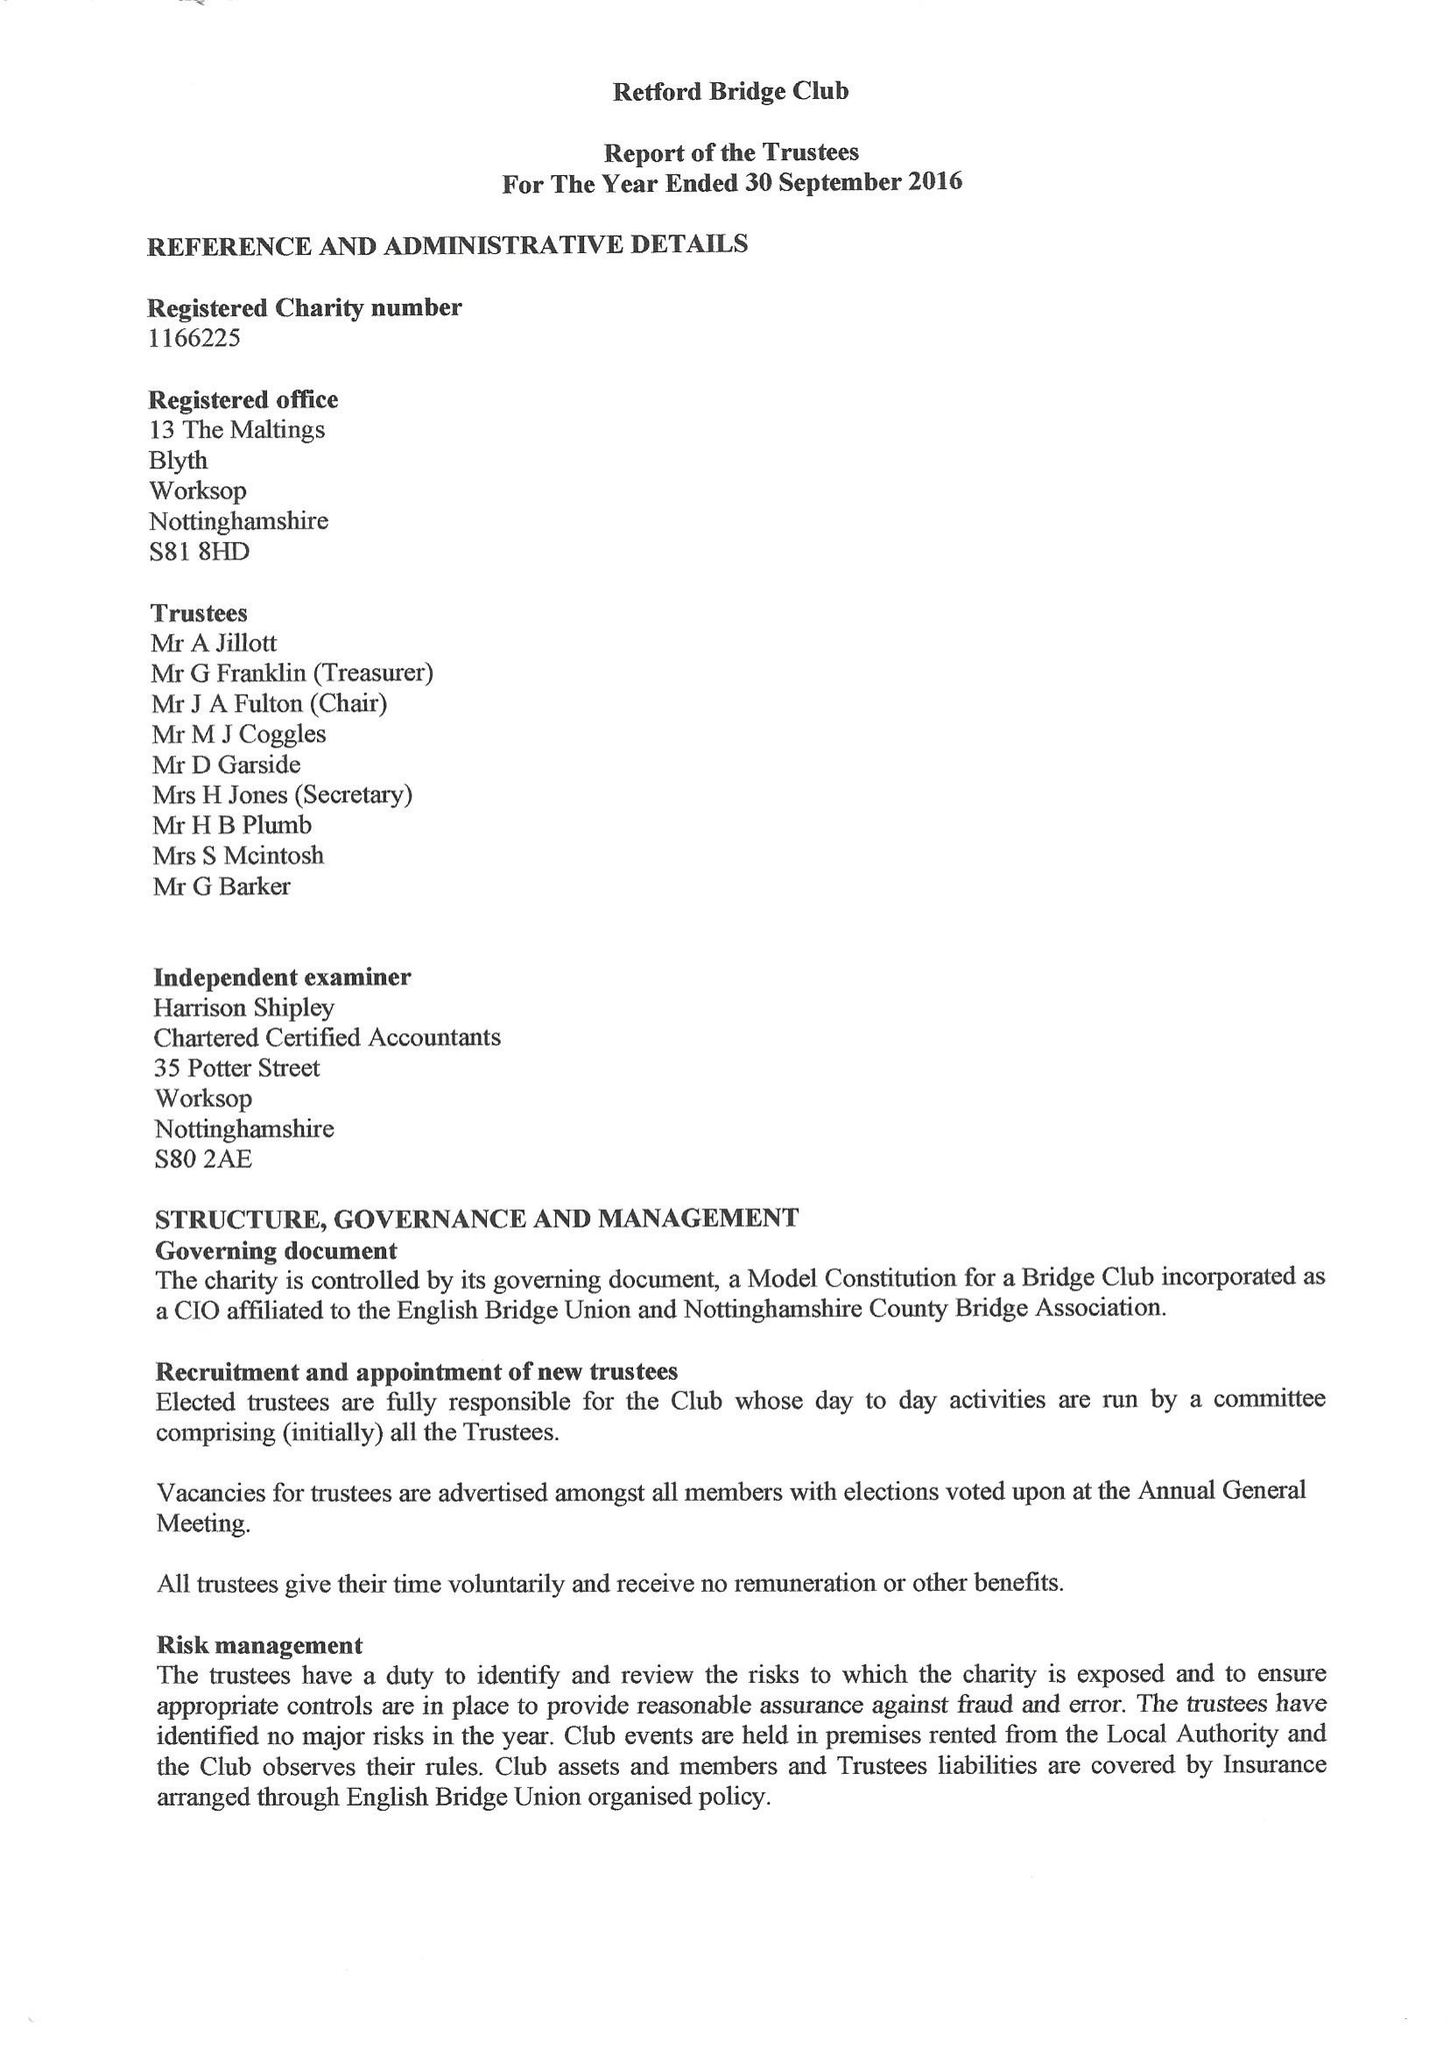What is the value for the income_annually_in_british_pounds?
Answer the question using a single word or phrase. 7999.33 